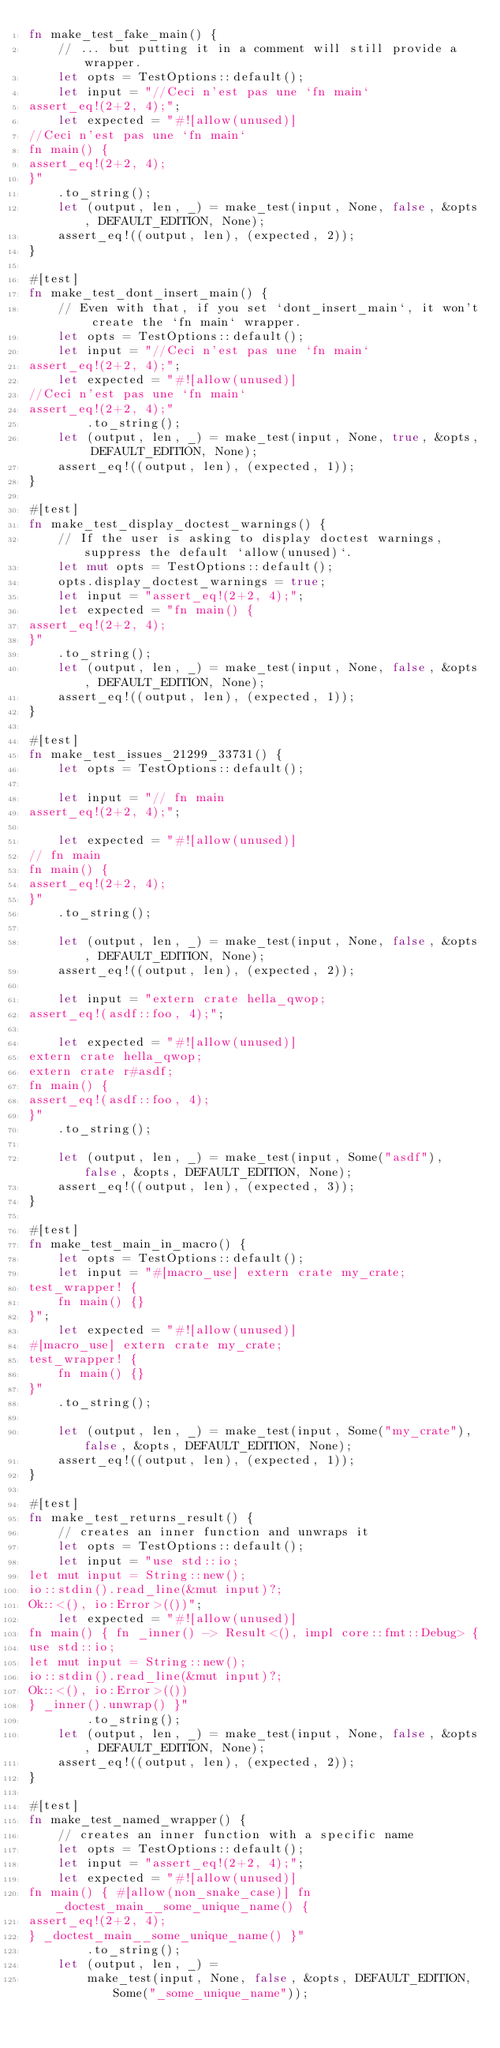Convert code to text. <code><loc_0><loc_0><loc_500><loc_500><_Rust_>fn make_test_fake_main() {
    // ... but putting it in a comment will still provide a wrapper.
    let opts = TestOptions::default();
    let input = "//Ceci n'est pas une `fn main`
assert_eq!(2+2, 4);";
    let expected = "#![allow(unused)]
//Ceci n'est pas une `fn main`
fn main() {
assert_eq!(2+2, 4);
}"
    .to_string();
    let (output, len, _) = make_test(input, None, false, &opts, DEFAULT_EDITION, None);
    assert_eq!((output, len), (expected, 2));
}

#[test]
fn make_test_dont_insert_main() {
    // Even with that, if you set `dont_insert_main`, it won't create the `fn main` wrapper.
    let opts = TestOptions::default();
    let input = "//Ceci n'est pas une `fn main`
assert_eq!(2+2, 4);";
    let expected = "#![allow(unused)]
//Ceci n'est pas une `fn main`
assert_eq!(2+2, 4);"
        .to_string();
    let (output, len, _) = make_test(input, None, true, &opts, DEFAULT_EDITION, None);
    assert_eq!((output, len), (expected, 1));
}

#[test]
fn make_test_display_doctest_warnings() {
    // If the user is asking to display doctest warnings, suppress the default `allow(unused)`.
    let mut opts = TestOptions::default();
    opts.display_doctest_warnings = true;
    let input = "assert_eq!(2+2, 4);";
    let expected = "fn main() {
assert_eq!(2+2, 4);
}"
    .to_string();
    let (output, len, _) = make_test(input, None, false, &opts, DEFAULT_EDITION, None);
    assert_eq!((output, len), (expected, 1));
}

#[test]
fn make_test_issues_21299_33731() {
    let opts = TestOptions::default();

    let input = "// fn main
assert_eq!(2+2, 4);";

    let expected = "#![allow(unused)]
// fn main
fn main() {
assert_eq!(2+2, 4);
}"
    .to_string();

    let (output, len, _) = make_test(input, None, false, &opts, DEFAULT_EDITION, None);
    assert_eq!((output, len), (expected, 2));

    let input = "extern crate hella_qwop;
assert_eq!(asdf::foo, 4);";

    let expected = "#![allow(unused)]
extern crate hella_qwop;
extern crate r#asdf;
fn main() {
assert_eq!(asdf::foo, 4);
}"
    .to_string();

    let (output, len, _) = make_test(input, Some("asdf"), false, &opts, DEFAULT_EDITION, None);
    assert_eq!((output, len), (expected, 3));
}

#[test]
fn make_test_main_in_macro() {
    let opts = TestOptions::default();
    let input = "#[macro_use] extern crate my_crate;
test_wrapper! {
    fn main() {}
}";
    let expected = "#![allow(unused)]
#[macro_use] extern crate my_crate;
test_wrapper! {
    fn main() {}
}"
    .to_string();

    let (output, len, _) = make_test(input, Some("my_crate"), false, &opts, DEFAULT_EDITION, None);
    assert_eq!((output, len), (expected, 1));
}

#[test]
fn make_test_returns_result() {
    // creates an inner function and unwraps it
    let opts = TestOptions::default();
    let input = "use std::io;
let mut input = String::new();
io::stdin().read_line(&mut input)?;
Ok::<(), io:Error>(())";
    let expected = "#![allow(unused)]
fn main() { fn _inner() -> Result<(), impl core::fmt::Debug> {
use std::io;
let mut input = String::new();
io::stdin().read_line(&mut input)?;
Ok::<(), io:Error>(())
} _inner().unwrap() }"
        .to_string();
    let (output, len, _) = make_test(input, None, false, &opts, DEFAULT_EDITION, None);
    assert_eq!((output, len), (expected, 2));
}

#[test]
fn make_test_named_wrapper() {
    // creates an inner function with a specific name
    let opts = TestOptions::default();
    let input = "assert_eq!(2+2, 4);";
    let expected = "#![allow(unused)]
fn main() { #[allow(non_snake_case)] fn _doctest_main__some_unique_name() {
assert_eq!(2+2, 4);
} _doctest_main__some_unique_name() }"
        .to_string();
    let (output, len, _) =
        make_test(input, None, false, &opts, DEFAULT_EDITION, Some("_some_unique_name"));</code> 